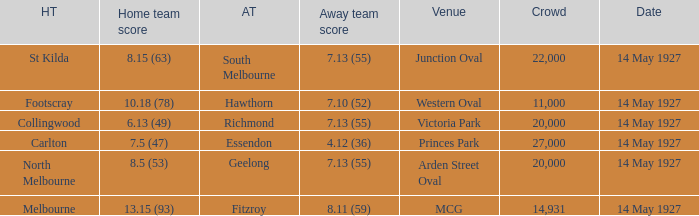Parse the table in full. {'header': ['HT', 'Home team score', 'AT', 'Away team score', 'Venue', 'Crowd', 'Date'], 'rows': [['St Kilda', '8.15 (63)', 'South Melbourne', '7.13 (55)', 'Junction Oval', '22,000', '14 May 1927'], ['Footscray', '10.18 (78)', 'Hawthorn', '7.10 (52)', 'Western Oval', '11,000', '14 May 1927'], ['Collingwood', '6.13 (49)', 'Richmond', '7.13 (55)', 'Victoria Park', '20,000', '14 May 1927'], ['Carlton', '7.5 (47)', 'Essendon', '4.12 (36)', 'Princes Park', '27,000', '14 May 1927'], ['North Melbourne', '8.5 (53)', 'Geelong', '7.13 (55)', 'Arden Street Oval', '20,000', '14 May 1927'], ['Melbourne', '13.15 (93)', 'Fitzroy', '8.11 (59)', 'MCG', '14,931', '14 May 1927']]} What was the home team when the Geelong away team had a score of 7.13 (55)? North Melbourne. 